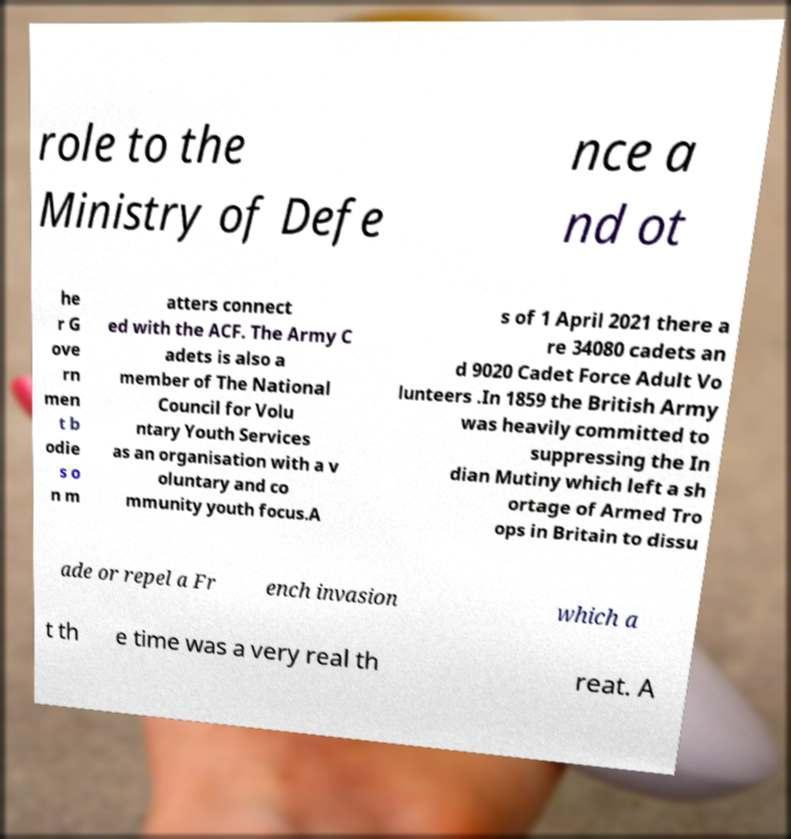Could you assist in decoding the text presented in this image and type it out clearly? role to the Ministry of Defe nce a nd ot he r G ove rn men t b odie s o n m atters connect ed with the ACF. The Army C adets is also a member of The National Council for Volu ntary Youth Services as an organisation with a v oluntary and co mmunity youth focus.A s of 1 April 2021 there a re 34080 cadets an d 9020 Cadet Force Adult Vo lunteers .In 1859 the British Army was heavily committed to suppressing the In dian Mutiny which left a sh ortage of Armed Tro ops in Britain to dissu ade or repel a Fr ench invasion which a t th e time was a very real th reat. A 